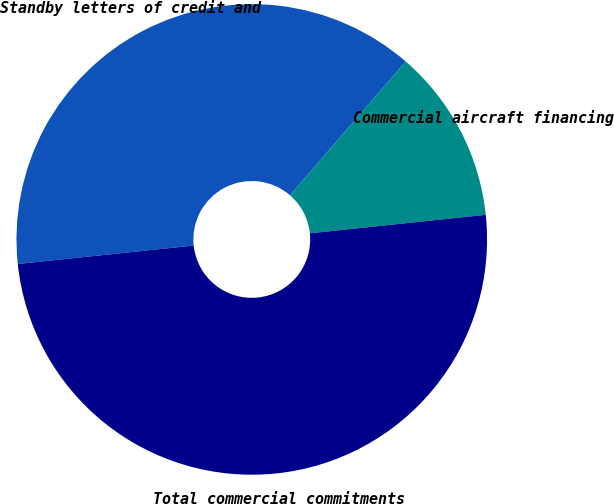<chart> <loc_0><loc_0><loc_500><loc_500><pie_chart><fcel>Standby letters of credit and<fcel>Commercial aircraft financing<fcel>Total commercial commitments<nl><fcel>38.02%<fcel>11.98%<fcel>50.0%<nl></chart> 